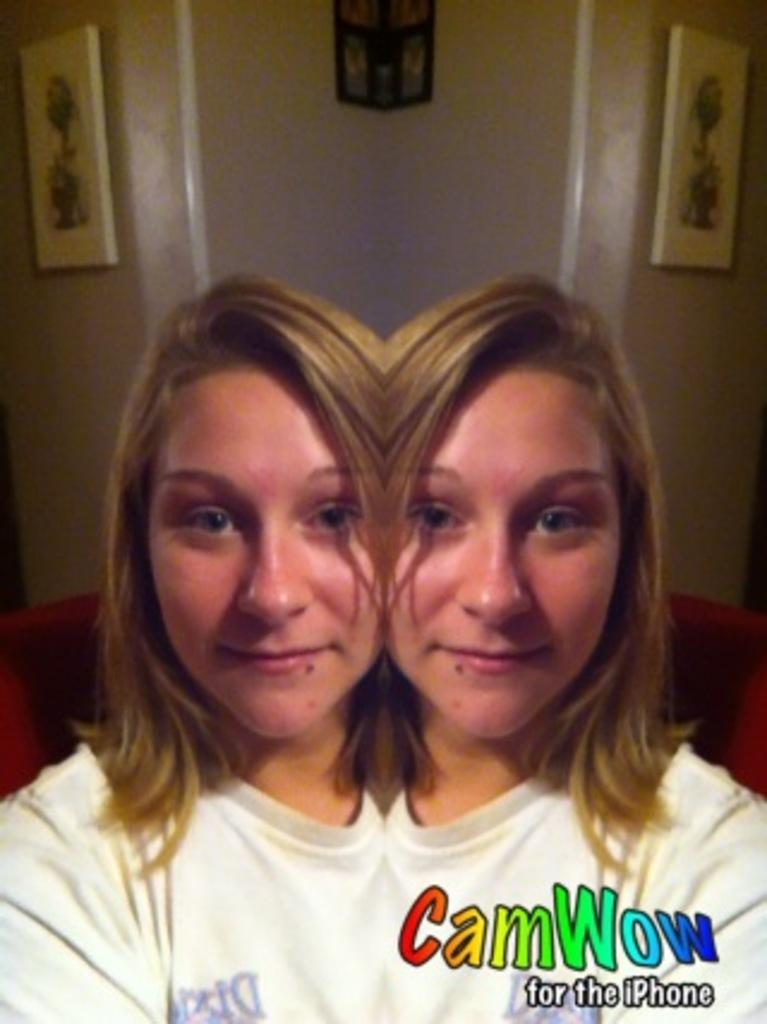Who is present in the image? There is a woman in the image. What is the woman's facial expression? The woman is smiling. What can be seen behind the woman? There is a wall behind the woman. What is hanging on the wall? There are picture frames on the wall. What is written or drawn on the wall? There is text on the wall in the bottom right corner. What type of yam is being prepared in the image? There is no yam or any indication of food preparation in the image. What is the aftermath of the event depicted in the image? There is no event or action taking place in the image that would have an aftermath. 